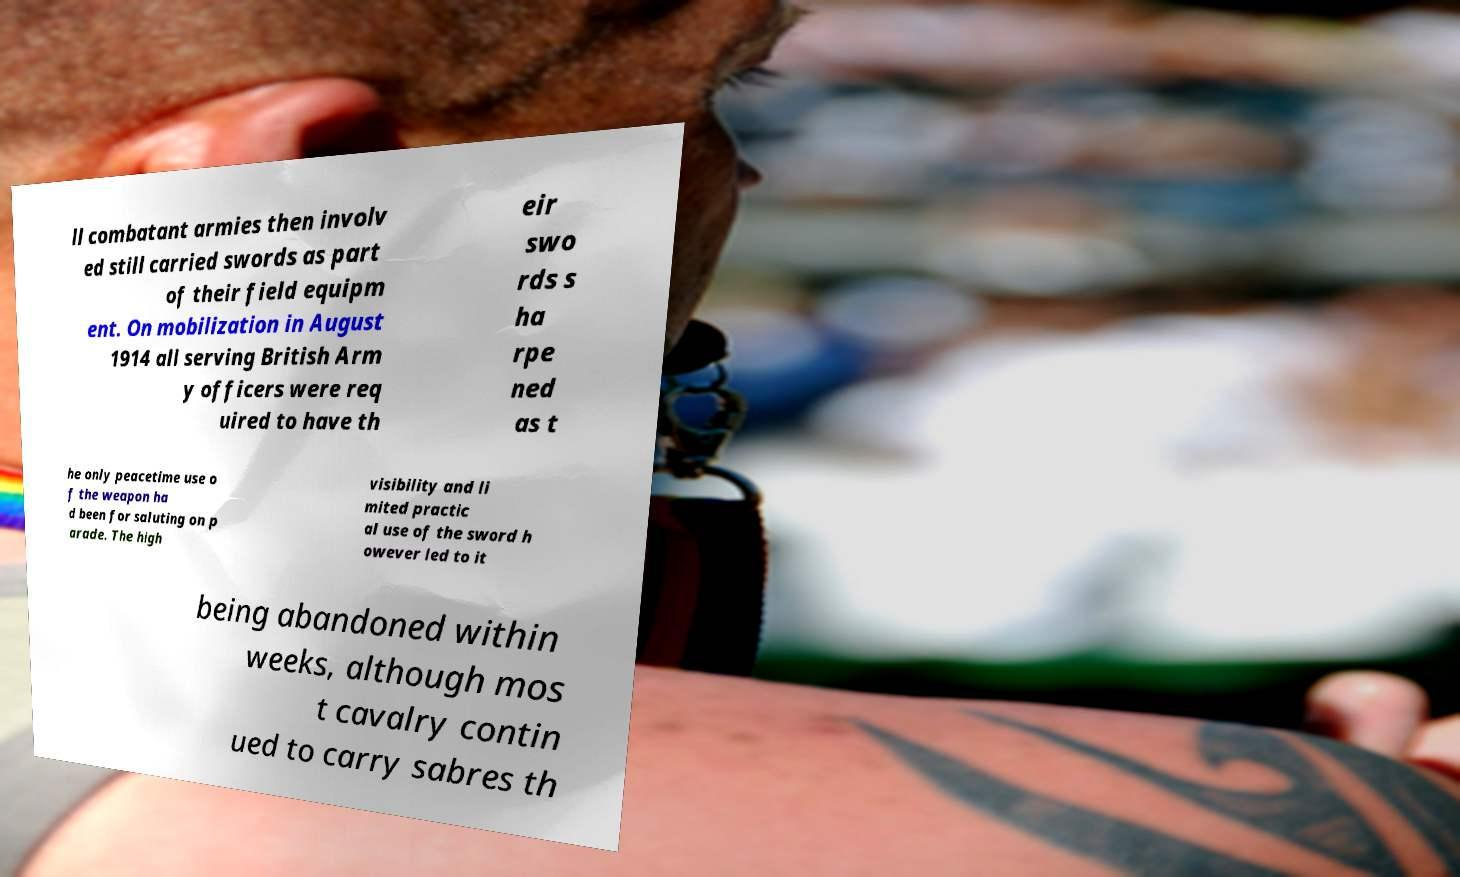Can you read and provide the text displayed in the image?This photo seems to have some interesting text. Can you extract and type it out for me? ll combatant armies then involv ed still carried swords as part of their field equipm ent. On mobilization in August 1914 all serving British Arm y officers were req uired to have th eir swo rds s ha rpe ned as t he only peacetime use o f the weapon ha d been for saluting on p arade. The high visibility and li mited practic al use of the sword h owever led to it being abandoned within weeks, although mos t cavalry contin ued to carry sabres th 